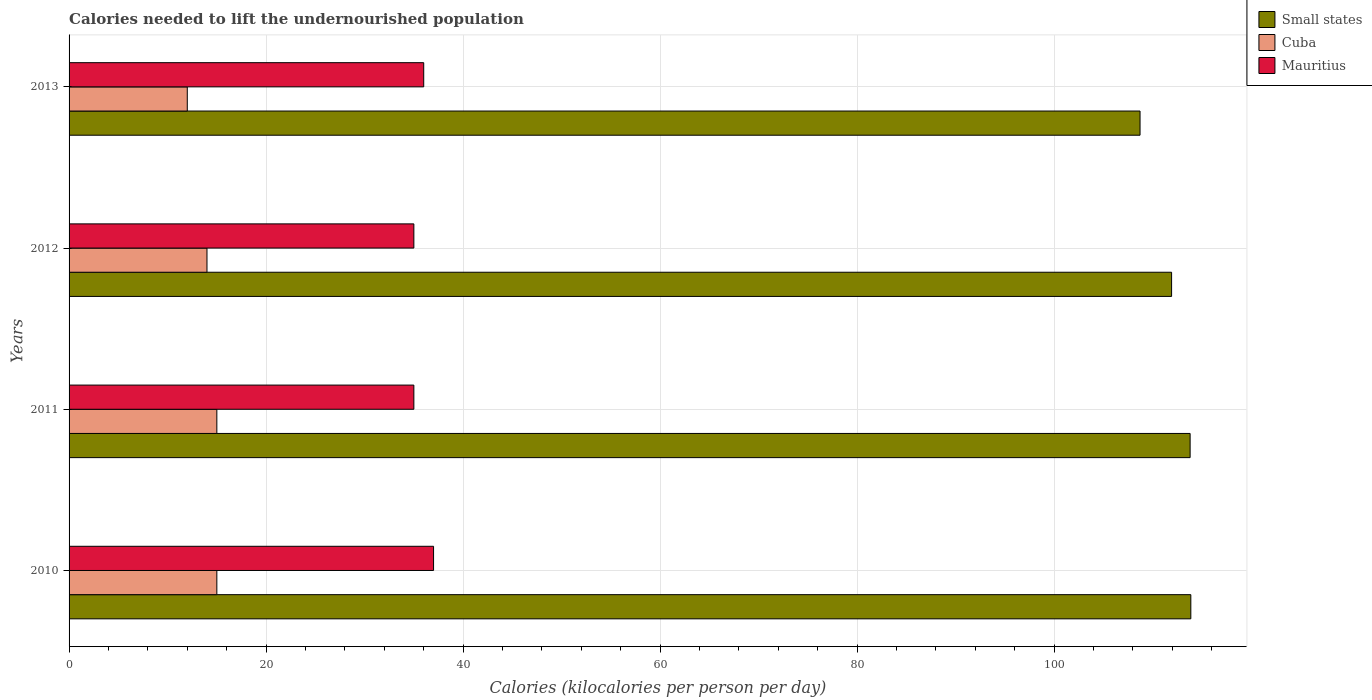Are the number of bars on each tick of the Y-axis equal?
Offer a very short reply. Yes. How many bars are there on the 1st tick from the top?
Provide a short and direct response. 3. How many bars are there on the 3rd tick from the bottom?
Ensure brevity in your answer.  3. What is the label of the 2nd group of bars from the top?
Provide a succinct answer. 2012. What is the total calories needed to lift the undernourished population in Small states in 2010?
Ensure brevity in your answer.  113.87. Across all years, what is the maximum total calories needed to lift the undernourished population in Cuba?
Your response must be concise. 15. Across all years, what is the minimum total calories needed to lift the undernourished population in Cuba?
Give a very brief answer. 12. In which year was the total calories needed to lift the undernourished population in Cuba minimum?
Provide a short and direct response. 2013. What is the total total calories needed to lift the undernourished population in Small states in the graph?
Provide a short and direct response. 448.3. What is the difference between the total calories needed to lift the undernourished population in Small states in 2010 and that in 2013?
Provide a short and direct response. 5.15. What is the difference between the total calories needed to lift the undernourished population in Cuba in 2011 and the total calories needed to lift the undernourished population in Small states in 2012?
Offer a terse response. -96.92. What is the average total calories needed to lift the undernourished population in Small states per year?
Provide a succinct answer. 112.08. In the year 2013, what is the difference between the total calories needed to lift the undernourished population in Small states and total calories needed to lift the undernourished population in Cuba?
Give a very brief answer. 96.72. In how many years, is the total calories needed to lift the undernourished population in Cuba greater than 16 kilocalories?
Offer a terse response. 0. What is the ratio of the total calories needed to lift the undernourished population in Small states in 2011 to that in 2013?
Offer a very short reply. 1.05. Is the difference between the total calories needed to lift the undernourished population in Small states in 2011 and 2013 greater than the difference between the total calories needed to lift the undernourished population in Cuba in 2011 and 2013?
Give a very brief answer. Yes. What is the difference between the highest and the lowest total calories needed to lift the undernourished population in Cuba?
Make the answer very short. 3. In how many years, is the total calories needed to lift the undernourished population in Small states greater than the average total calories needed to lift the undernourished population in Small states taken over all years?
Ensure brevity in your answer.  2. What does the 1st bar from the top in 2011 represents?
Your answer should be compact. Mauritius. What does the 3rd bar from the bottom in 2010 represents?
Your answer should be very brief. Mauritius. Are all the bars in the graph horizontal?
Provide a succinct answer. Yes. How many years are there in the graph?
Provide a short and direct response. 4. What is the difference between two consecutive major ticks on the X-axis?
Make the answer very short. 20. Does the graph contain any zero values?
Make the answer very short. No. Where does the legend appear in the graph?
Ensure brevity in your answer.  Top right. What is the title of the graph?
Provide a succinct answer. Calories needed to lift the undernourished population. Does "Fiji" appear as one of the legend labels in the graph?
Offer a very short reply. No. What is the label or title of the X-axis?
Make the answer very short. Calories (kilocalories per person per day). What is the label or title of the Y-axis?
Provide a short and direct response. Years. What is the Calories (kilocalories per person per day) of Small states in 2010?
Your response must be concise. 113.87. What is the Calories (kilocalories per person per day) of Cuba in 2010?
Keep it short and to the point. 15. What is the Calories (kilocalories per person per day) in Small states in 2011?
Ensure brevity in your answer.  113.8. What is the Calories (kilocalories per person per day) of Cuba in 2011?
Provide a succinct answer. 15. What is the Calories (kilocalories per person per day) in Mauritius in 2011?
Give a very brief answer. 35. What is the Calories (kilocalories per person per day) in Small states in 2012?
Provide a short and direct response. 111.92. What is the Calories (kilocalories per person per day) of Cuba in 2012?
Offer a very short reply. 14. What is the Calories (kilocalories per person per day) in Mauritius in 2012?
Provide a succinct answer. 35. What is the Calories (kilocalories per person per day) of Small states in 2013?
Ensure brevity in your answer.  108.72. What is the Calories (kilocalories per person per day) in Cuba in 2013?
Offer a very short reply. 12. What is the Calories (kilocalories per person per day) in Mauritius in 2013?
Provide a succinct answer. 36. Across all years, what is the maximum Calories (kilocalories per person per day) of Small states?
Your response must be concise. 113.87. Across all years, what is the maximum Calories (kilocalories per person per day) of Mauritius?
Your answer should be very brief. 37. Across all years, what is the minimum Calories (kilocalories per person per day) in Small states?
Give a very brief answer. 108.72. Across all years, what is the minimum Calories (kilocalories per person per day) of Cuba?
Your response must be concise. 12. Across all years, what is the minimum Calories (kilocalories per person per day) of Mauritius?
Provide a succinct answer. 35. What is the total Calories (kilocalories per person per day) in Small states in the graph?
Offer a terse response. 448.3. What is the total Calories (kilocalories per person per day) in Cuba in the graph?
Provide a short and direct response. 56. What is the total Calories (kilocalories per person per day) of Mauritius in the graph?
Offer a terse response. 143. What is the difference between the Calories (kilocalories per person per day) in Small states in 2010 and that in 2011?
Ensure brevity in your answer.  0.07. What is the difference between the Calories (kilocalories per person per day) of Cuba in 2010 and that in 2011?
Offer a very short reply. 0. What is the difference between the Calories (kilocalories per person per day) of Mauritius in 2010 and that in 2011?
Provide a short and direct response. 2. What is the difference between the Calories (kilocalories per person per day) in Small states in 2010 and that in 2012?
Provide a succinct answer. 1.95. What is the difference between the Calories (kilocalories per person per day) in Cuba in 2010 and that in 2012?
Offer a very short reply. 1. What is the difference between the Calories (kilocalories per person per day) of Small states in 2010 and that in 2013?
Your answer should be compact. 5.15. What is the difference between the Calories (kilocalories per person per day) in Mauritius in 2010 and that in 2013?
Provide a short and direct response. 1. What is the difference between the Calories (kilocalories per person per day) of Small states in 2011 and that in 2012?
Ensure brevity in your answer.  1.88. What is the difference between the Calories (kilocalories per person per day) in Cuba in 2011 and that in 2012?
Provide a short and direct response. 1. What is the difference between the Calories (kilocalories per person per day) in Small states in 2011 and that in 2013?
Give a very brief answer. 5.08. What is the difference between the Calories (kilocalories per person per day) in Mauritius in 2011 and that in 2013?
Make the answer very short. -1. What is the difference between the Calories (kilocalories per person per day) in Small states in 2012 and that in 2013?
Make the answer very short. 3.2. What is the difference between the Calories (kilocalories per person per day) in Small states in 2010 and the Calories (kilocalories per person per day) in Cuba in 2011?
Ensure brevity in your answer.  98.87. What is the difference between the Calories (kilocalories per person per day) in Small states in 2010 and the Calories (kilocalories per person per day) in Mauritius in 2011?
Your answer should be compact. 78.87. What is the difference between the Calories (kilocalories per person per day) of Cuba in 2010 and the Calories (kilocalories per person per day) of Mauritius in 2011?
Your response must be concise. -20. What is the difference between the Calories (kilocalories per person per day) of Small states in 2010 and the Calories (kilocalories per person per day) of Cuba in 2012?
Ensure brevity in your answer.  99.87. What is the difference between the Calories (kilocalories per person per day) in Small states in 2010 and the Calories (kilocalories per person per day) in Mauritius in 2012?
Offer a terse response. 78.87. What is the difference between the Calories (kilocalories per person per day) of Small states in 2010 and the Calories (kilocalories per person per day) of Cuba in 2013?
Ensure brevity in your answer.  101.87. What is the difference between the Calories (kilocalories per person per day) of Small states in 2010 and the Calories (kilocalories per person per day) of Mauritius in 2013?
Ensure brevity in your answer.  77.87. What is the difference between the Calories (kilocalories per person per day) in Cuba in 2010 and the Calories (kilocalories per person per day) in Mauritius in 2013?
Offer a very short reply. -21. What is the difference between the Calories (kilocalories per person per day) of Small states in 2011 and the Calories (kilocalories per person per day) of Cuba in 2012?
Keep it short and to the point. 99.8. What is the difference between the Calories (kilocalories per person per day) in Small states in 2011 and the Calories (kilocalories per person per day) in Mauritius in 2012?
Keep it short and to the point. 78.8. What is the difference between the Calories (kilocalories per person per day) in Cuba in 2011 and the Calories (kilocalories per person per day) in Mauritius in 2012?
Ensure brevity in your answer.  -20. What is the difference between the Calories (kilocalories per person per day) in Small states in 2011 and the Calories (kilocalories per person per day) in Cuba in 2013?
Give a very brief answer. 101.8. What is the difference between the Calories (kilocalories per person per day) of Small states in 2011 and the Calories (kilocalories per person per day) of Mauritius in 2013?
Your answer should be compact. 77.8. What is the difference between the Calories (kilocalories per person per day) in Cuba in 2011 and the Calories (kilocalories per person per day) in Mauritius in 2013?
Provide a short and direct response. -21. What is the difference between the Calories (kilocalories per person per day) in Small states in 2012 and the Calories (kilocalories per person per day) in Cuba in 2013?
Offer a terse response. 99.92. What is the difference between the Calories (kilocalories per person per day) in Small states in 2012 and the Calories (kilocalories per person per day) in Mauritius in 2013?
Give a very brief answer. 75.92. What is the difference between the Calories (kilocalories per person per day) in Cuba in 2012 and the Calories (kilocalories per person per day) in Mauritius in 2013?
Give a very brief answer. -22. What is the average Calories (kilocalories per person per day) of Small states per year?
Make the answer very short. 112.08. What is the average Calories (kilocalories per person per day) of Cuba per year?
Provide a short and direct response. 14. What is the average Calories (kilocalories per person per day) of Mauritius per year?
Offer a very short reply. 35.75. In the year 2010, what is the difference between the Calories (kilocalories per person per day) in Small states and Calories (kilocalories per person per day) in Cuba?
Ensure brevity in your answer.  98.87. In the year 2010, what is the difference between the Calories (kilocalories per person per day) of Small states and Calories (kilocalories per person per day) of Mauritius?
Your answer should be compact. 76.87. In the year 2011, what is the difference between the Calories (kilocalories per person per day) of Small states and Calories (kilocalories per person per day) of Cuba?
Your response must be concise. 98.8. In the year 2011, what is the difference between the Calories (kilocalories per person per day) of Small states and Calories (kilocalories per person per day) of Mauritius?
Your answer should be compact. 78.8. In the year 2011, what is the difference between the Calories (kilocalories per person per day) of Cuba and Calories (kilocalories per person per day) of Mauritius?
Give a very brief answer. -20. In the year 2012, what is the difference between the Calories (kilocalories per person per day) in Small states and Calories (kilocalories per person per day) in Cuba?
Ensure brevity in your answer.  97.92. In the year 2012, what is the difference between the Calories (kilocalories per person per day) in Small states and Calories (kilocalories per person per day) in Mauritius?
Ensure brevity in your answer.  76.92. In the year 2013, what is the difference between the Calories (kilocalories per person per day) in Small states and Calories (kilocalories per person per day) in Cuba?
Offer a very short reply. 96.72. In the year 2013, what is the difference between the Calories (kilocalories per person per day) of Small states and Calories (kilocalories per person per day) of Mauritius?
Ensure brevity in your answer.  72.72. What is the ratio of the Calories (kilocalories per person per day) in Small states in 2010 to that in 2011?
Offer a terse response. 1. What is the ratio of the Calories (kilocalories per person per day) of Mauritius in 2010 to that in 2011?
Offer a very short reply. 1.06. What is the ratio of the Calories (kilocalories per person per day) of Small states in 2010 to that in 2012?
Make the answer very short. 1.02. What is the ratio of the Calories (kilocalories per person per day) in Cuba in 2010 to that in 2012?
Provide a succinct answer. 1.07. What is the ratio of the Calories (kilocalories per person per day) of Mauritius in 2010 to that in 2012?
Make the answer very short. 1.06. What is the ratio of the Calories (kilocalories per person per day) of Small states in 2010 to that in 2013?
Make the answer very short. 1.05. What is the ratio of the Calories (kilocalories per person per day) of Cuba in 2010 to that in 2013?
Your response must be concise. 1.25. What is the ratio of the Calories (kilocalories per person per day) in Mauritius in 2010 to that in 2013?
Keep it short and to the point. 1.03. What is the ratio of the Calories (kilocalories per person per day) of Small states in 2011 to that in 2012?
Offer a very short reply. 1.02. What is the ratio of the Calories (kilocalories per person per day) in Cuba in 2011 to that in 2012?
Offer a very short reply. 1.07. What is the ratio of the Calories (kilocalories per person per day) in Small states in 2011 to that in 2013?
Offer a very short reply. 1.05. What is the ratio of the Calories (kilocalories per person per day) of Cuba in 2011 to that in 2013?
Ensure brevity in your answer.  1.25. What is the ratio of the Calories (kilocalories per person per day) of Mauritius in 2011 to that in 2013?
Make the answer very short. 0.97. What is the ratio of the Calories (kilocalories per person per day) of Small states in 2012 to that in 2013?
Offer a very short reply. 1.03. What is the ratio of the Calories (kilocalories per person per day) in Cuba in 2012 to that in 2013?
Your answer should be compact. 1.17. What is the ratio of the Calories (kilocalories per person per day) in Mauritius in 2012 to that in 2013?
Provide a succinct answer. 0.97. What is the difference between the highest and the second highest Calories (kilocalories per person per day) in Small states?
Make the answer very short. 0.07. What is the difference between the highest and the lowest Calories (kilocalories per person per day) of Small states?
Provide a short and direct response. 5.15. 